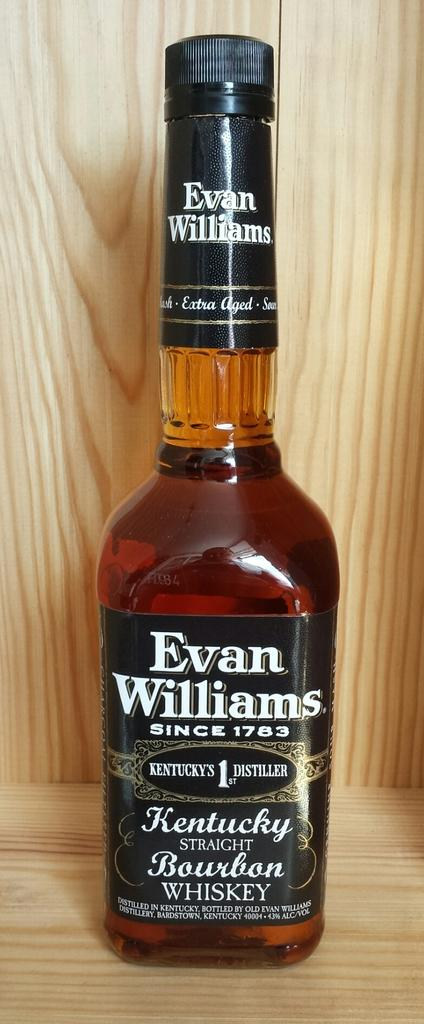Provide a one-sentence caption for the provided image. A bottle of Evan Williams sitting on a wood shelf. 